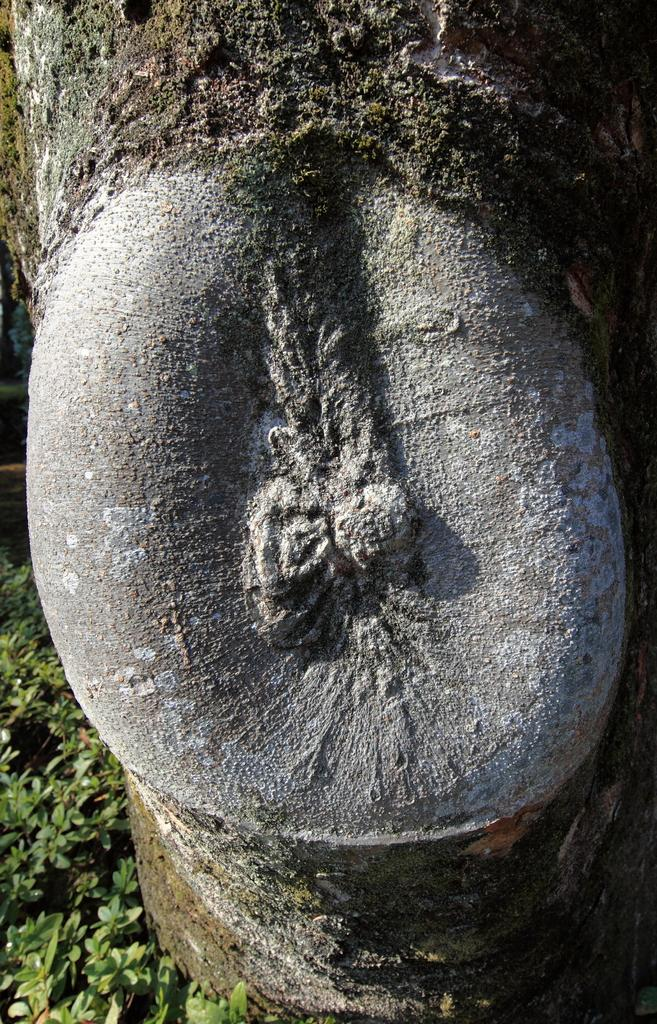What is the main subject in the image? The main subject in the image is a tree trunk. Are there any other plants visible in the image? Yes, there are plants in the left side bottom corner of the image. How many balls can be seen rolling on the sand near the tree trunk in the image? There are no balls or sand present in the image; it features a tree trunk and plants. 